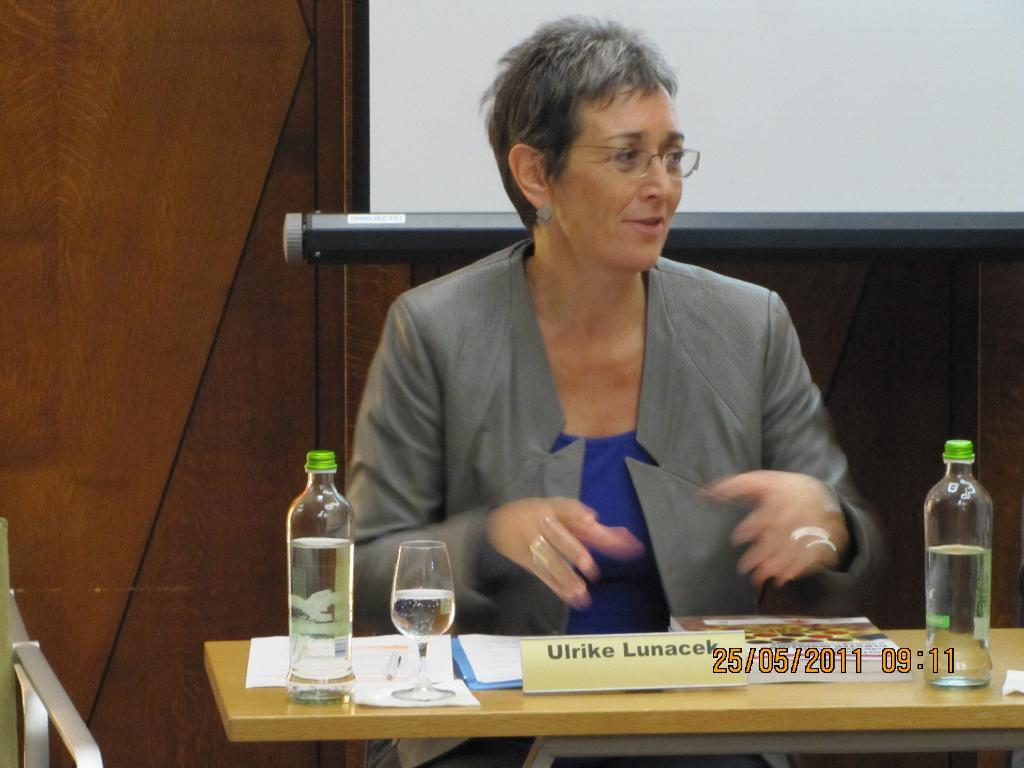<image>
Write a terse but informative summary of the picture. Ulrike Lunacek sits at a desk on May 25, 2011 